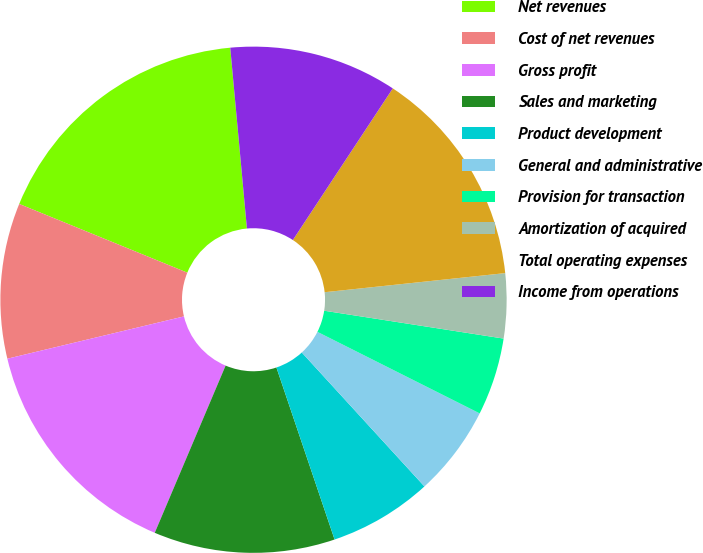Convert chart to OTSL. <chart><loc_0><loc_0><loc_500><loc_500><pie_chart><fcel>Net revenues<fcel>Cost of net revenues<fcel>Gross profit<fcel>Sales and marketing<fcel>Product development<fcel>General and administrative<fcel>Provision for transaction<fcel>Amortization of acquired<fcel>Total operating expenses<fcel>Income from operations<nl><fcel>17.36%<fcel>9.92%<fcel>14.88%<fcel>11.57%<fcel>6.61%<fcel>5.79%<fcel>4.96%<fcel>4.13%<fcel>14.05%<fcel>10.74%<nl></chart> 